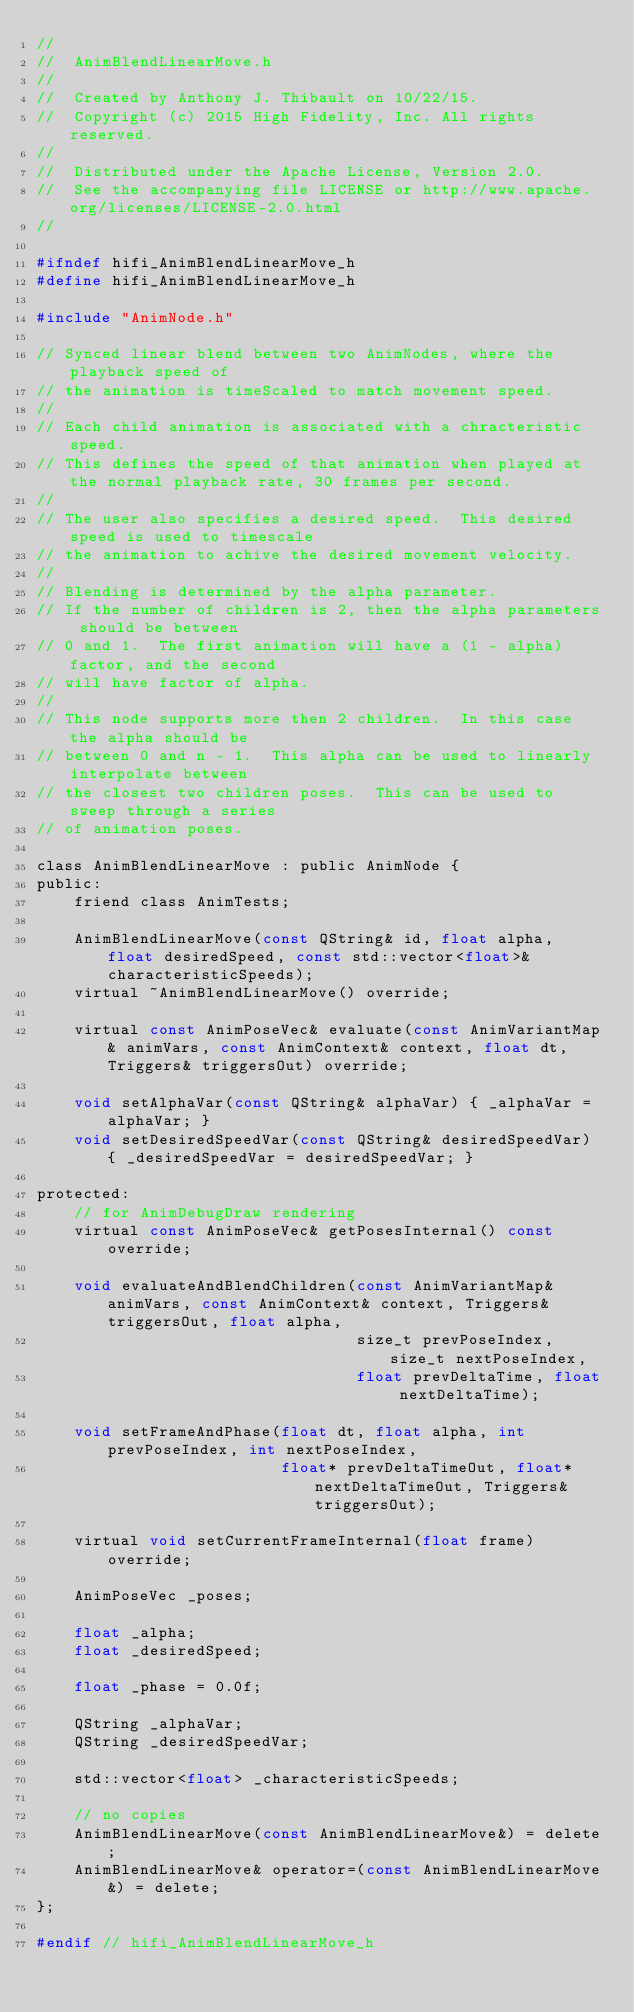Convert code to text. <code><loc_0><loc_0><loc_500><loc_500><_C_>//
//  AnimBlendLinearMove.h
//
//  Created by Anthony J. Thibault on 10/22/15.
//  Copyright (c) 2015 High Fidelity, Inc. All rights reserved.
//
//  Distributed under the Apache License, Version 2.0.
//  See the accompanying file LICENSE or http://www.apache.org/licenses/LICENSE-2.0.html
//

#ifndef hifi_AnimBlendLinearMove_h
#define hifi_AnimBlendLinearMove_h

#include "AnimNode.h"

// Synced linear blend between two AnimNodes, where the playback speed of
// the animation is timeScaled to match movement speed.
//
// Each child animation is associated with a chracteristic speed.
// This defines the speed of that animation when played at the normal playback rate, 30 frames per second.
//
// The user also specifies a desired speed.  This desired speed is used to timescale
// the animation to achive the desired movement velocity.
//
// Blending is determined by the alpha parameter.
// If the number of children is 2, then the alpha parameters should be between
// 0 and 1.  The first animation will have a (1 - alpha) factor, and the second
// will have factor of alpha.
//
// This node supports more then 2 children.  In this case the alpha should be
// between 0 and n - 1.  This alpha can be used to linearly interpolate between
// the closest two children poses.  This can be used to sweep through a series
// of animation poses.

class AnimBlendLinearMove : public AnimNode {
public:
    friend class AnimTests;

    AnimBlendLinearMove(const QString& id, float alpha, float desiredSpeed, const std::vector<float>& characteristicSpeeds);
    virtual ~AnimBlendLinearMove() override;

    virtual const AnimPoseVec& evaluate(const AnimVariantMap& animVars, const AnimContext& context, float dt, Triggers& triggersOut) override;

    void setAlphaVar(const QString& alphaVar) { _alphaVar = alphaVar; }
    void setDesiredSpeedVar(const QString& desiredSpeedVar) { _desiredSpeedVar = desiredSpeedVar; }

protected:
    // for AnimDebugDraw rendering
    virtual const AnimPoseVec& getPosesInternal() const override;

    void evaluateAndBlendChildren(const AnimVariantMap& animVars, const AnimContext& context, Triggers& triggersOut, float alpha,
                                  size_t prevPoseIndex, size_t nextPoseIndex,
                                  float prevDeltaTime, float nextDeltaTime);

    void setFrameAndPhase(float dt, float alpha, int prevPoseIndex, int nextPoseIndex,
                          float* prevDeltaTimeOut, float* nextDeltaTimeOut, Triggers& triggersOut);

    virtual void setCurrentFrameInternal(float frame) override;

    AnimPoseVec _poses;

    float _alpha;
    float _desiredSpeed;

    float _phase = 0.0f;

    QString _alphaVar;
    QString _desiredSpeedVar;

    std::vector<float> _characteristicSpeeds;

    // no copies
    AnimBlendLinearMove(const AnimBlendLinearMove&) = delete;
    AnimBlendLinearMove& operator=(const AnimBlendLinearMove&) = delete;
};

#endif // hifi_AnimBlendLinearMove_h
</code> 